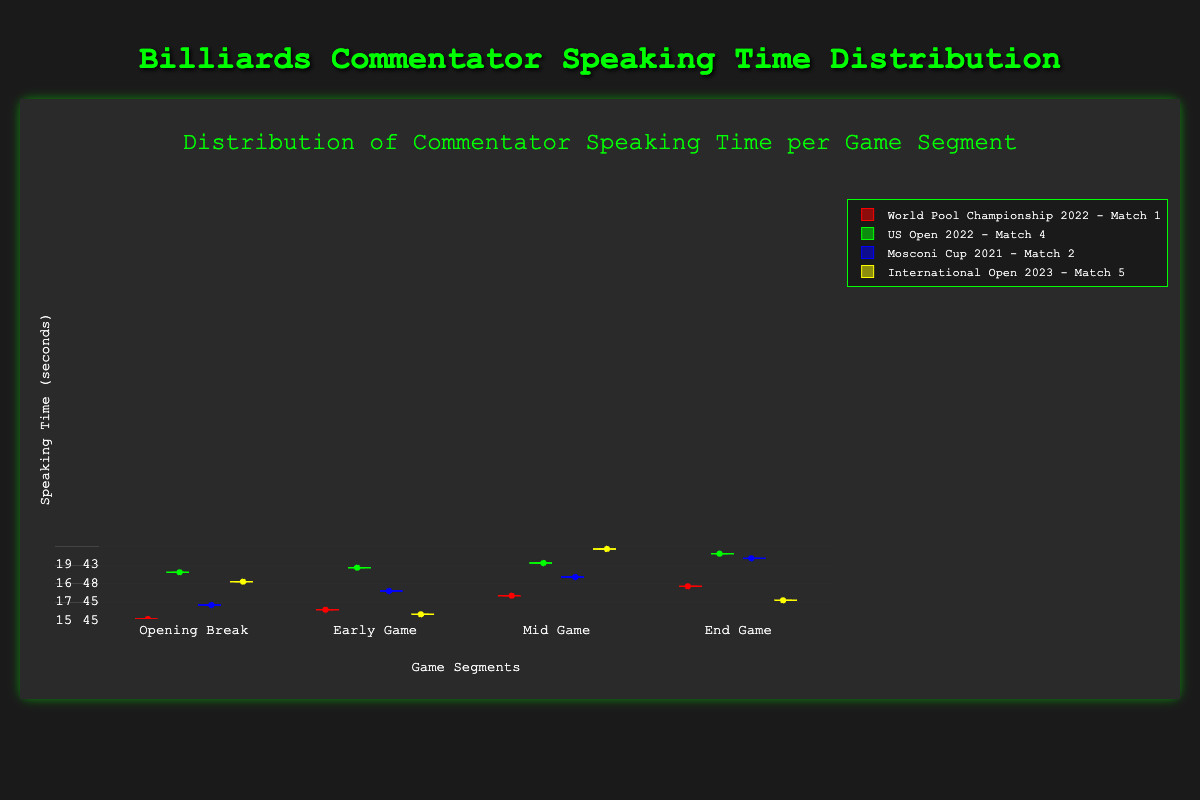What is the title of the chart? The title is located at the top of the chart and clearly states the main purpose of the visualization.
Answer: Distribution of Commentator Speaking Time per Game Segment Which game segment has the longer median speaking time overall? To determine this, compare the median lines (middle line in each box) across all game segments for each match.
Answer: Mid Game In which match does the commentator have the longest median speaking time during the "End Game" segment? Look at the median lines within the "End Game" boxes for each match to see which is the highest.
Answer: US Open 2022 - Match 4 How does the speaking time variability in the "Final Shots" segment of the "Mosconi Cup 2021 - Match 2" compare to other matches? Examine the size of the boxes (interquartile range - the distance between the first and third quartiles) for the "Final Shots" segment of each match.
Answer: The variability is larger in "Mosconi Cup 2021 - Match 2" compared to others During which match and game segment is the commentator's speaking time the least consistent? The least consistent speaking time can be identified by finding the largest box, which indicates a wider interquartile range, and the length of the whiskers.
Answer: Mid Game of Mosconi Cup 2021 - Match 2 Which game segment shows the smallest range (difference between maximum and minimum values) of speaking time for the "World Pool Championship 2022 - Match 1"? Look for the segment in "World Pool Championship 2022 - Match 1" where the distance between the minimum and maximum whiskers is the shortest.
Answer: Opening Break What is the median speaking time during the "Early Game" segment for "World Pool Championship 2022 - Match 1"? Locate the median line within the "Early Game" box for "World Pool Championship 2022 - Match 1".
Answer: 45.5 seconds How does the median speaking time in the "Opening Break" segment compare across all matches? Compare the median lines within the "Opening Break" boxes for each match.
Answer: Varies from 15 to 20 seconds Which game segment has the largest interquartile range (box height) for "International Open 2023 - Match 5"? By visually assessing the height of the boxes for "International Open 2023 - Match 5", determine which segment has the largest box.
Answer: Mid Game Which match shows a clear outlier during the "End Game" segment? Identify the game segment and match with a point far outside the whiskers (which represent the range without outliers).
Answer: None 